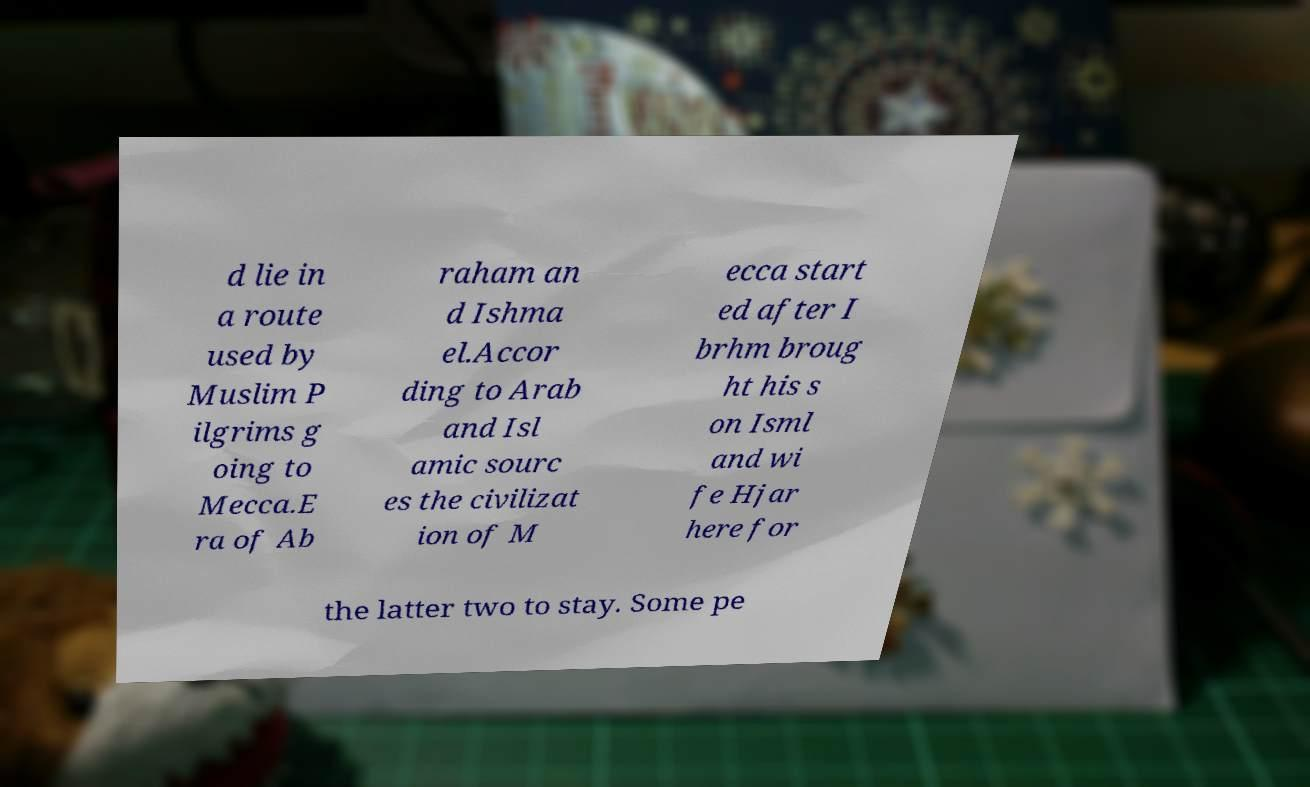There's text embedded in this image that I need extracted. Can you transcribe it verbatim? d lie in a route used by Muslim P ilgrims g oing to Mecca.E ra of Ab raham an d Ishma el.Accor ding to Arab and Isl amic sourc es the civilizat ion of M ecca start ed after I brhm broug ht his s on Isml and wi fe Hjar here for the latter two to stay. Some pe 